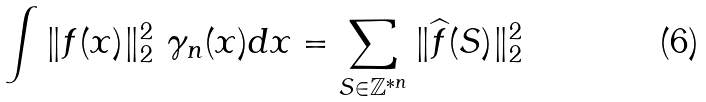<formula> <loc_0><loc_0><loc_500><loc_500>\int \| f ( x ) \| _ { 2 } ^ { 2 } \ \gamma _ { n } ( x ) d x = \sum _ { S \in \mathbb { Z } ^ { \ast n } } \| \widehat { f } ( S ) \| _ { 2 } ^ { 2 }</formula> 